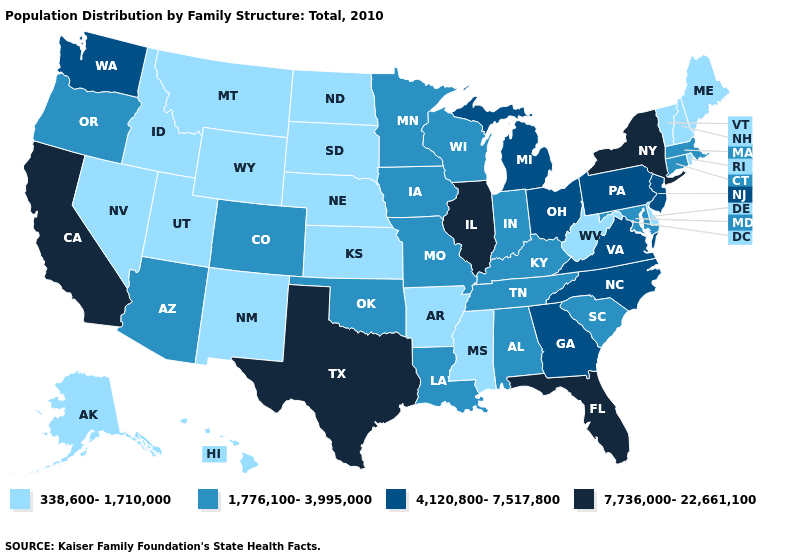Name the states that have a value in the range 338,600-1,710,000?
Give a very brief answer. Alaska, Arkansas, Delaware, Hawaii, Idaho, Kansas, Maine, Mississippi, Montana, Nebraska, Nevada, New Hampshire, New Mexico, North Dakota, Rhode Island, South Dakota, Utah, Vermont, West Virginia, Wyoming. Does Maine have the same value as Arizona?
Be succinct. No. Name the states that have a value in the range 7,736,000-22,661,100?
Answer briefly. California, Florida, Illinois, New York, Texas. What is the highest value in states that border Idaho?
Write a very short answer. 4,120,800-7,517,800. What is the highest value in states that border Minnesota?
Answer briefly. 1,776,100-3,995,000. Among the states that border Kansas , which have the lowest value?
Write a very short answer. Nebraska. Which states have the lowest value in the Northeast?
Answer briefly. Maine, New Hampshire, Rhode Island, Vermont. Does New Jersey have a higher value than North Carolina?
Short answer required. No. Which states have the highest value in the USA?
Be succinct. California, Florida, Illinois, New York, Texas. Name the states that have a value in the range 4,120,800-7,517,800?
Keep it brief. Georgia, Michigan, New Jersey, North Carolina, Ohio, Pennsylvania, Virginia, Washington. What is the lowest value in the USA?
Write a very short answer. 338,600-1,710,000. Does the first symbol in the legend represent the smallest category?
Be succinct. Yes. How many symbols are there in the legend?
Be succinct. 4. Name the states that have a value in the range 7,736,000-22,661,100?
Answer briefly. California, Florida, Illinois, New York, Texas. Does the map have missing data?
Concise answer only. No. 